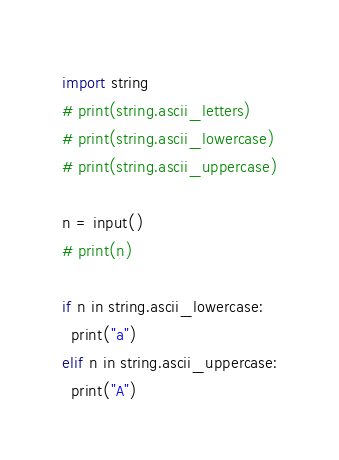Convert code to text. <code><loc_0><loc_0><loc_500><loc_500><_Python_>import string
# print(string.ascii_letters)
# print(string.ascii_lowercase)
# print(string.ascii_uppercase)

n = input()
# print(n)

if n in string.ascii_lowercase:
  print("a")
elif n in string.ascii_uppercase:
  print("A")</code> 